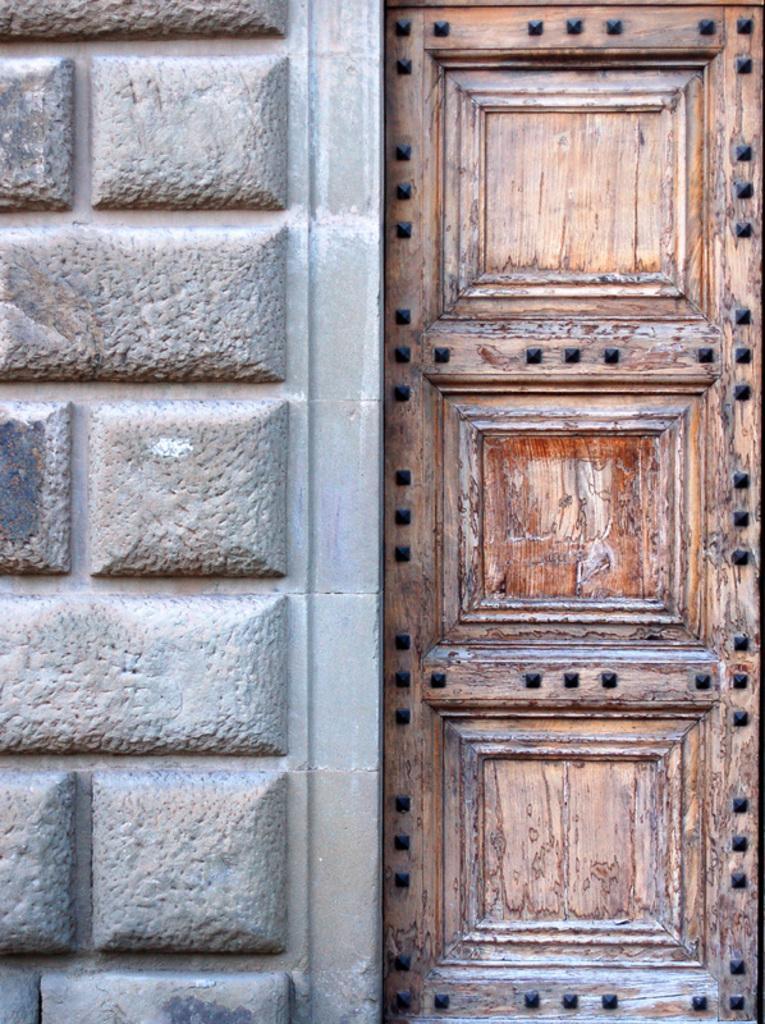Could you give a brief overview of what you see in this image? In this image on the right side there is one door, and on the left side there is a wall. 